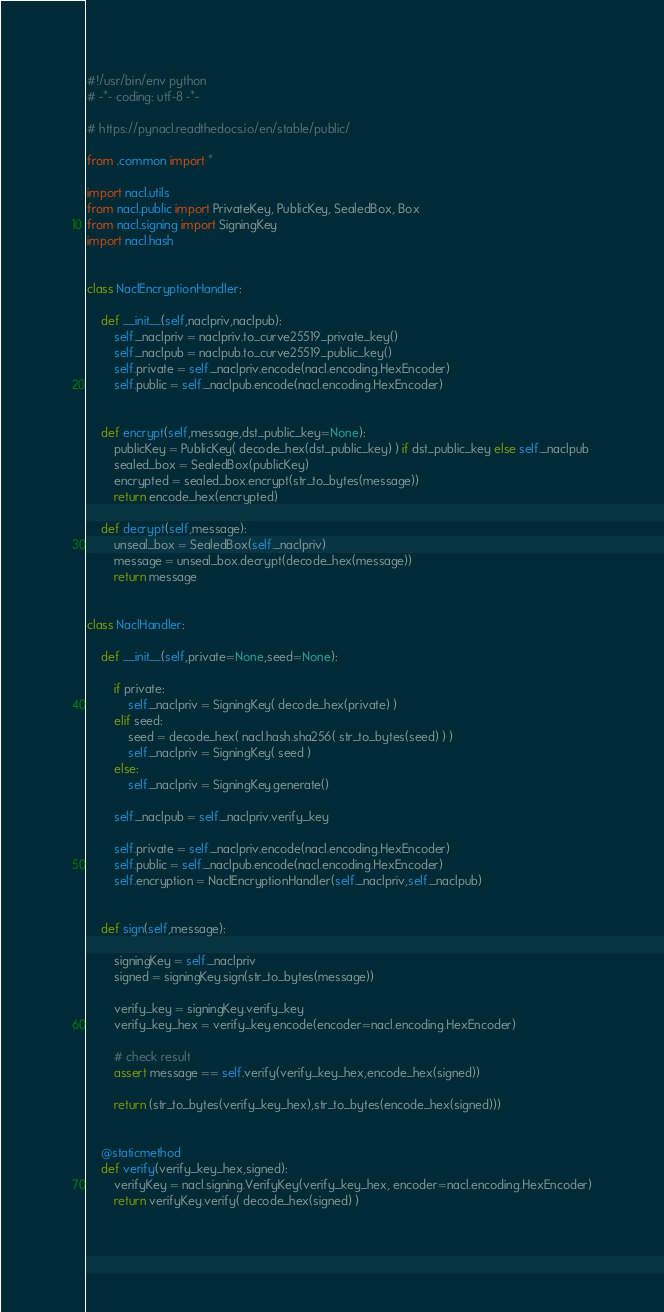Convert code to text. <code><loc_0><loc_0><loc_500><loc_500><_Python_>#!/usr/bin/env python
# -*- coding: utf-8 -*-

# https://pynacl.readthedocs.io/en/stable/public/

from .common import *

import nacl.utils
from nacl.public import PrivateKey, PublicKey, SealedBox, Box
from nacl.signing import SigningKey
import nacl.hash


class NaclEncryptionHandler:

    def __init__(self,naclpriv,naclpub):
        self._naclpriv = naclpriv.to_curve25519_private_key()
        self._naclpub = naclpub.to_curve25519_public_key()
        self.private = self._naclpriv.encode(nacl.encoding.HexEncoder)
        self.public = self._naclpub.encode(nacl.encoding.HexEncoder)


    def encrypt(self,message,dst_public_key=None):
        publicKey = PublicKey( decode_hex(dst_public_key) ) if dst_public_key else self._naclpub
        sealed_box = SealedBox(publicKey)
        encrypted = sealed_box.encrypt(str_to_bytes(message))
        return encode_hex(encrypted)

    def decrypt(self,message):
        unseal_box = SealedBox(self._naclpriv)
        message = unseal_box.decrypt(decode_hex(message))
        return message


class NaclHandler:

    def __init__(self,private=None,seed=None):

        if private:
            self._naclpriv = SigningKey( decode_hex(private) )
        elif seed:
            seed = decode_hex( nacl.hash.sha256( str_to_bytes(seed) ) )
            self._naclpriv = SigningKey( seed )
        else:
            self._naclpriv = SigningKey.generate()
            
        self._naclpub = self._naclpriv.verify_key
        
        self.private = self._naclpriv.encode(nacl.encoding.HexEncoder)
        self.public = self._naclpub.encode(nacl.encoding.HexEncoder)
        self.encryption = NaclEncryptionHandler(self._naclpriv,self._naclpub)


    def sign(self,message):

        signingKey = self._naclpriv
        signed = signingKey.sign(str_to_bytes(message))
        
        verify_key = signingKey.verify_key
        verify_key_hex = verify_key.encode(encoder=nacl.encoding.HexEncoder)

        # check result
        assert message == self.verify(verify_key_hex,encode_hex(signed))
        
        return (str_to_bytes(verify_key_hex),str_to_bytes(encode_hex(signed)))
        

    @staticmethod
    def verify(verify_key_hex,signed):
        verifyKey = nacl.signing.VerifyKey(verify_key_hex, encoder=nacl.encoding.HexEncoder)
        return verifyKey.verify( decode_hex(signed) )

        
</code> 